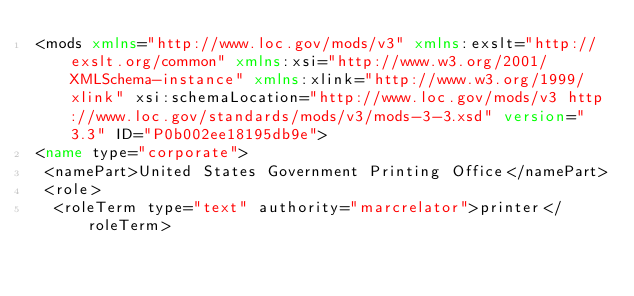<code> <loc_0><loc_0><loc_500><loc_500><_XML_><mods xmlns="http://www.loc.gov/mods/v3" xmlns:exslt="http://exslt.org/common" xmlns:xsi="http://www.w3.org/2001/XMLSchema-instance" xmlns:xlink="http://www.w3.org/1999/xlink" xsi:schemaLocation="http://www.loc.gov/mods/v3 http://www.loc.gov/standards/mods/v3/mods-3-3.xsd" version="3.3" ID="P0b002ee18195db9e">
<name type="corporate">
 <namePart>United States Government Printing Office</namePart>
 <role>
  <roleTerm type="text" authority="marcrelator">printer</roleTerm></code> 